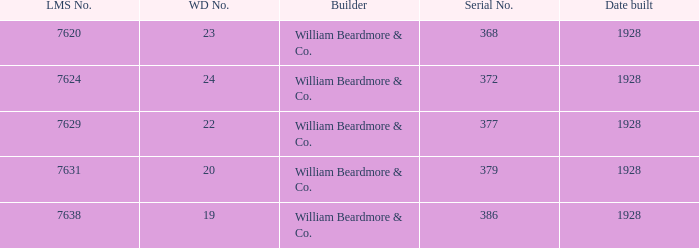Identify the lms figure for the serial number 37 7624.0. 